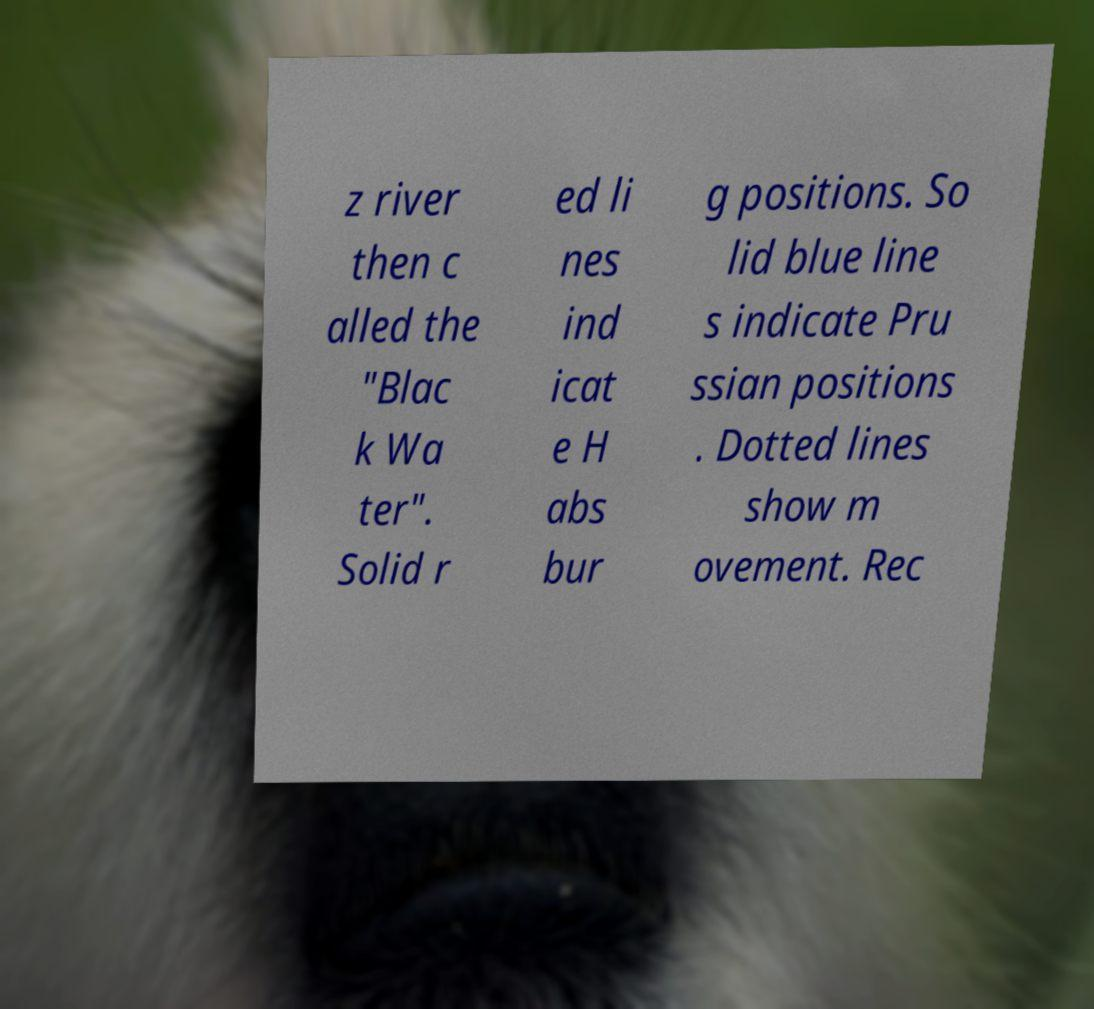Could you assist in decoding the text presented in this image and type it out clearly? z river then c alled the "Blac k Wa ter". Solid r ed li nes ind icat e H abs bur g positions. So lid blue line s indicate Pru ssian positions . Dotted lines show m ovement. Rec 